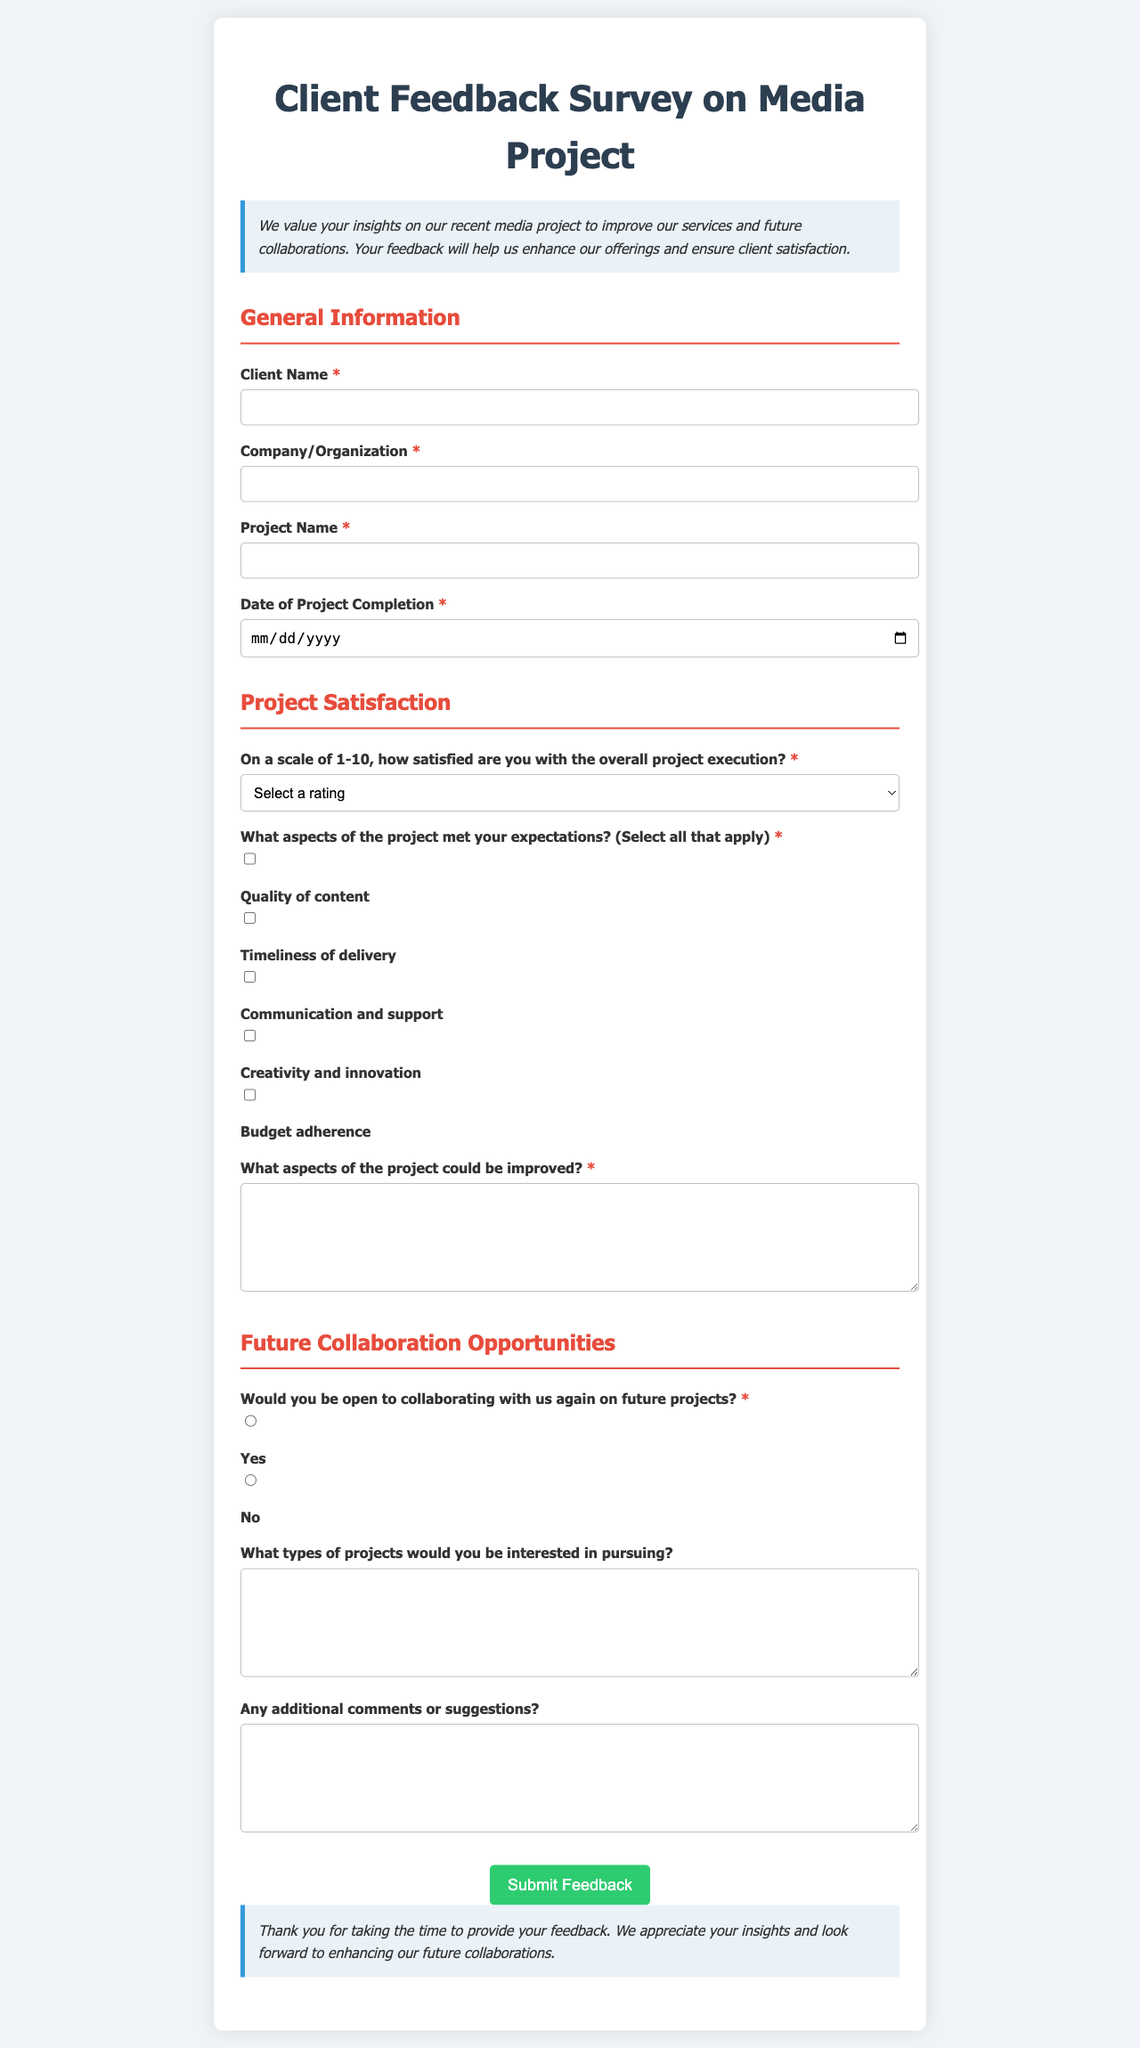What is the title of the document? The title is specified in the <title> tag of the HTML document.
Answer: Client Feedback Survey on Media Project What is the required client satisfaction rating range? The document specifies a satisfaction scale from 1 to 10 in the Project Satisfaction section.
Answer: 1-10 What types of projects are the clients asked about for future collaboration? The form requests clients to specify project types of interest in the Future Collaboration Opportunities section.
Answer: Future projects What is the color used for the conclusion section's background? The background color for the conclusion section is specified in the CSS as a light blue shade.
Answer: Light blue Which aspect of the project has a checkbox for quality of content? The checkbox labeled "Quality of content" is found in the Project Satisfaction section under aspects that met expectations.
Answer: Quality of content What is the maximum number of feedback options in the aspects that could be improved? The textarea in the Project Satisfaction section allows clients to specify any number of improvement aspects.
Answer: Unlimited Would a client be able to indicate dissatisfaction? The document has a required question about project satisfaction, where a very low score indicates potential dissatisfaction.
Answer: Yes Is client feedback collected through radio buttons? The section for future collaboration uses radio buttons for clients to indicate their willingness to collaborate again.
Answer: Yes 